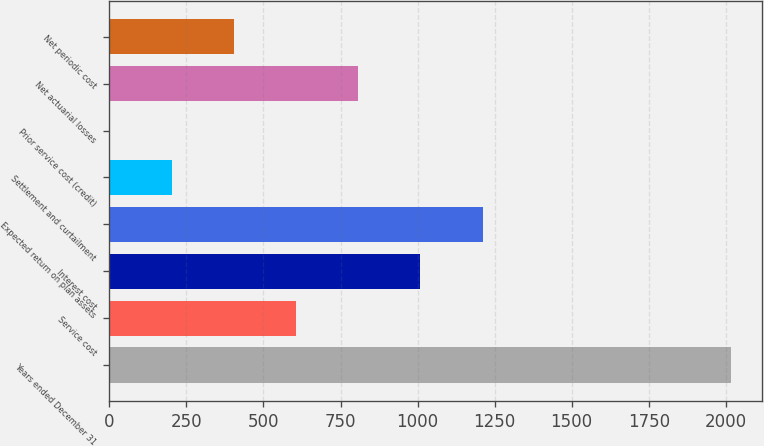<chart> <loc_0><loc_0><loc_500><loc_500><bar_chart><fcel>Years ended December 31<fcel>Service cost<fcel>Interest cost<fcel>Expected return on plan assets<fcel>Settlement and curtailment<fcel>Prior service cost (credit)<fcel>Net actuarial losses<fcel>Net periodic cost<nl><fcel>2018<fcel>605.47<fcel>1009.05<fcel>1210.84<fcel>201.89<fcel>0.1<fcel>807.26<fcel>403.68<nl></chart> 